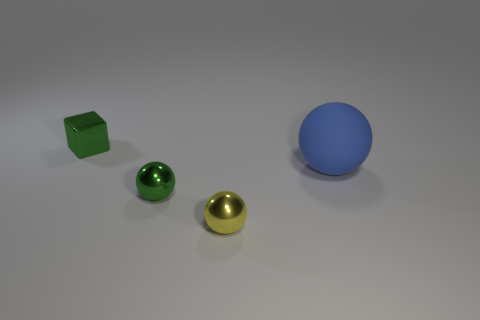Can you estimate the relative sizes of these objects? Based on the image, the blue sphere appears to be the largest object, followed by the green cube. The two spheres, one golden and the other green, look smaller in size with the golden one being slightly larger than its green counterpart. 